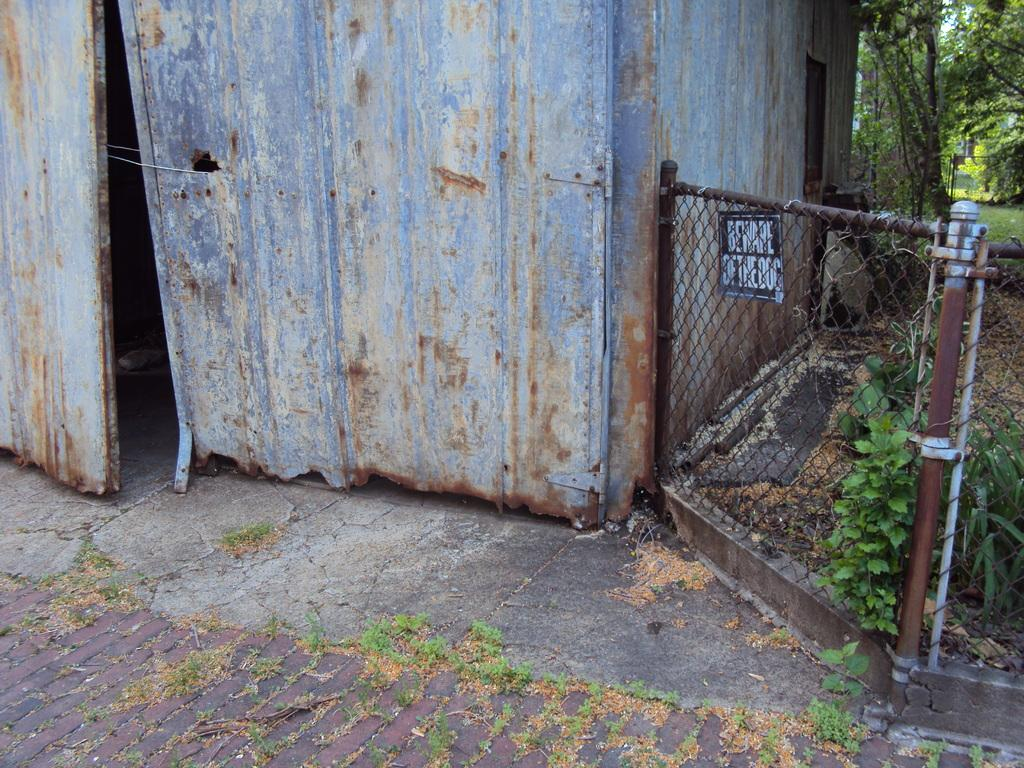What is covering the floor in the image? There are shredded leaves on the floor. What type of structures can be seen in the image? There are fences in the image. What type of information might be conveyed by the sign boards in the image? The sign boards in the image might convey information about directions, rules, or warnings. What type of vegetation is present in the image? There are trees and creepers visible in the image. What type of building can be seen in the image? There is a shed in the image. What type of reward is being given to the parent in the image? There is no parent or reward present in the image. What type of battle is taking place in the image? There is no battle present in the image. 